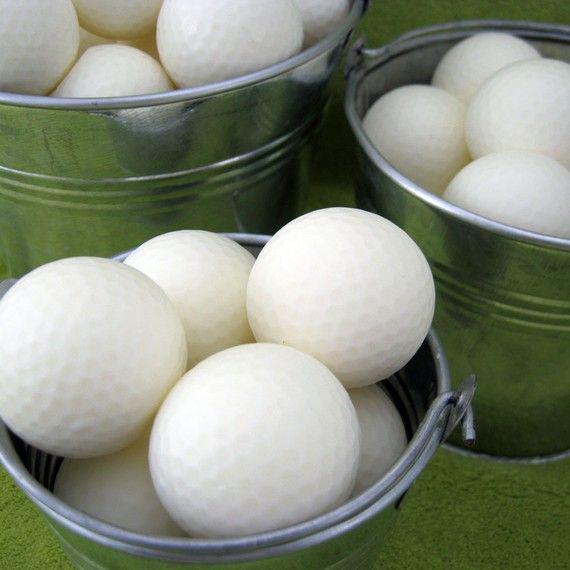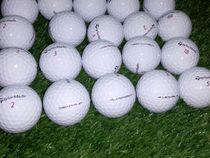The first image is the image on the left, the second image is the image on the right. For the images shown, is this caption "There are multiple golf balls in each image, and no visible containers." true? Answer yes or no. No. 